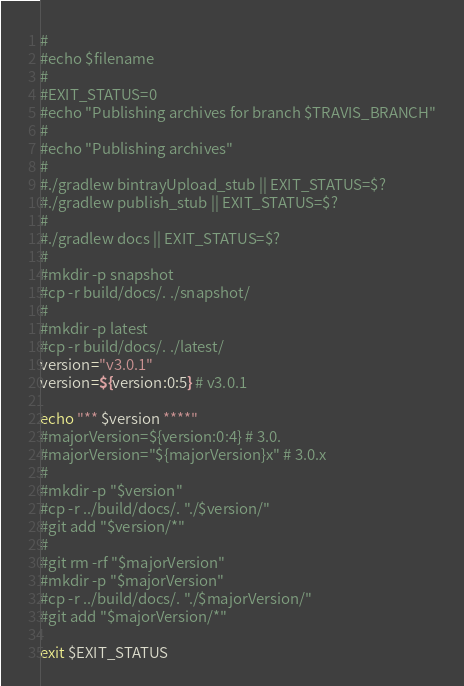Convert code to text. <code><loc_0><loc_0><loc_500><loc_500><_Bash_>#
#echo $filename
#
#EXIT_STATUS=0
#echo "Publishing archives for branch $TRAVIS_BRANCH"
#
#echo "Publishing archives"
#
#./gradlew bintrayUpload_stub || EXIT_STATUS=$?
#./gradlew publish_stub || EXIT_STATUS=$?
#
#./gradlew docs || EXIT_STATUS=$?
#
#mkdir -p snapshot
#cp -r build/docs/. ./snapshot/
#
#mkdir -p latest
#cp -r build/docs/. ./latest/
version="v3.0.1"
version=${version:0:5} # v3.0.1

echo "** $version ****"
#majorVersion=${version:0:4} # 3.0.
#majorVersion="${majorVersion}x" # 3.0.x
#
#mkdir -p "$version"
#cp -r ../build/docs/. "./$version/"
#git add "$version/*"
#
#git rm -rf "$majorVersion"
#mkdir -p "$majorVersion"
#cp -r ../build/docs/. "./$majorVersion/"
#git add "$majorVersion/*"

exit $EXIT_STATUS
</code> 